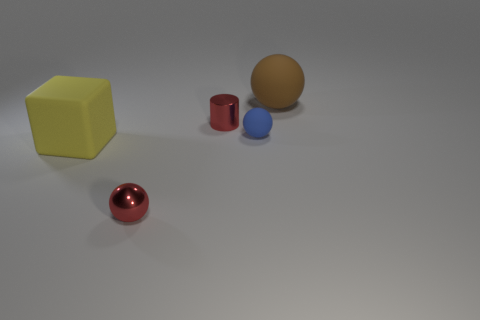Subtract all metallic balls. How many balls are left? 2 Add 3 yellow cubes. How many objects exist? 8 Subtract all brown balls. How many balls are left? 2 Subtract 1 blocks. How many blocks are left? 0 Subtract all cylinders. How many objects are left? 4 Add 2 small red metal objects. How many small red metal objects are left? 4 Add 5 brown objects. How many brown objects exist? 6 Subtract 0 green balls. How many objects are left? 5 Subtract all blue spheres. Subtract all gray cylinders. How many spheres are left? 2 Subtract all cyan blocks. How many cyan cylinders are left? 0 